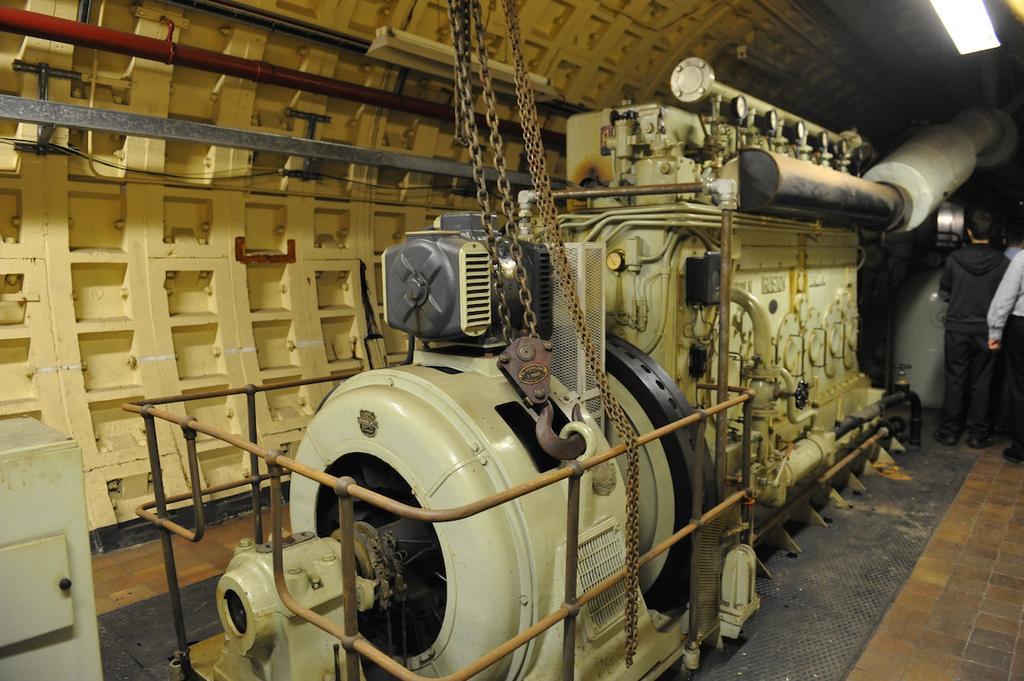Could you give a brief overview of what you see in this image? In this image, we can see machines, chains, rods and pipes. On the right side of the image, we can see light and people standing on the floor. On the left side of the image, there is a box with a handle. In the middle of the image, we can see chain with hook attached to the ring. 